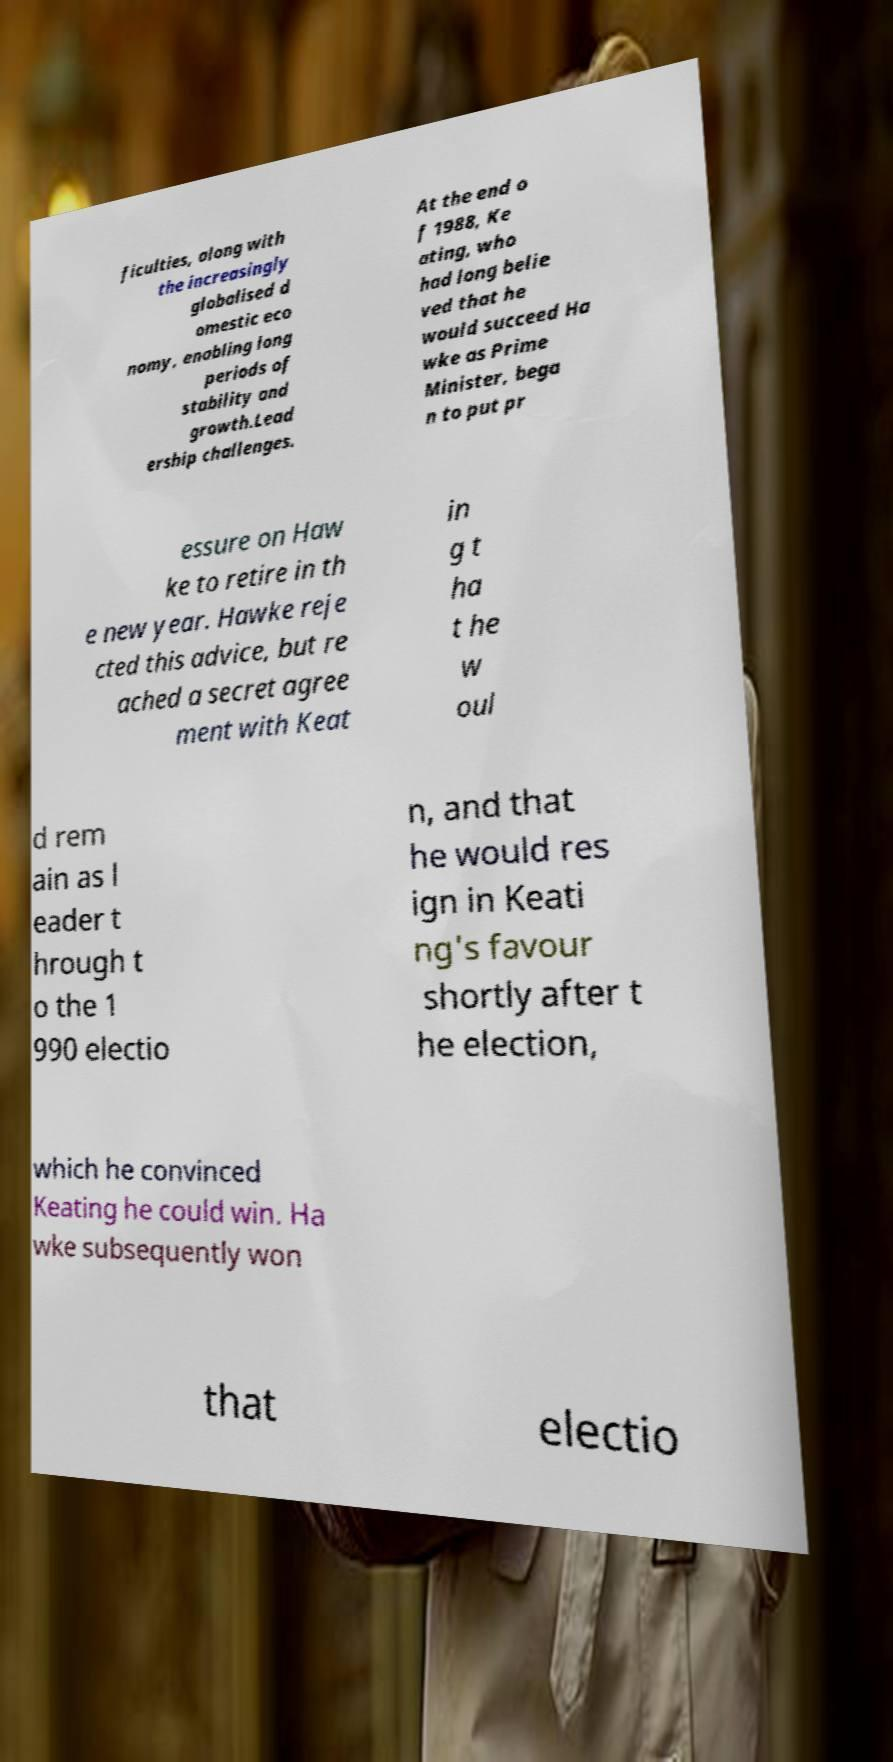Can you read and provide the text displayed in the image?This photo seems to have some interesting text. Can you extract and type it out for me? ficulties, along with the increasingly globalised d omestic eco nomy, enabling long periods of stability and growth.Lead ership challenges. At the end o f 1988, Ke ating, who had long belie ved that he would succeed Ha wke as Prime Minister, bega n to put pr essure on Haw ke to retire in th e new year. Hawke reje cted this advice, but re ached a secret agree ment with Keat in g t ha t he w oul d rem ain as l eader t hrough t o the 1 990 electio n, and that he would res ign in Keati ng's favour shortly after t he election, which he convinced Keating he could win. Ha wke subsequently won that electio 